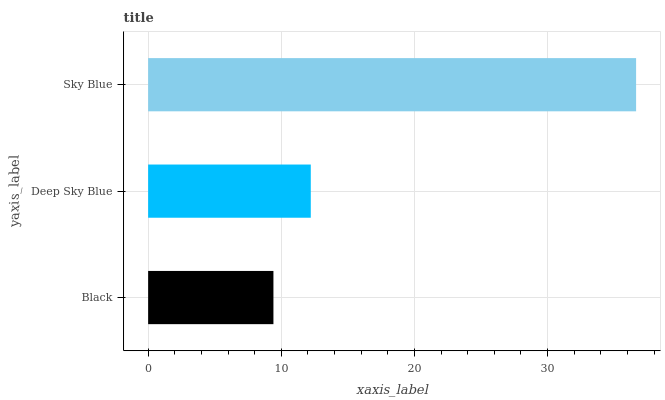Is Black the minimum?
Answer yes or no. Yes. Is Sky Blue the maximum?
Answer yes or no. Yes. Is Deep Sky Blue the minimum?
Answer yes or no. No. Is Deep Sky Blue the maximum?
Answer yes or no. No. Is Deep Sky Blue greater than Black?
Answer yes or no. Yes. Is Black less than Deep Sky Blue?
Answer yes or no. Yes. Is Black greater than Deep Sky Blue?
Answer yes or no. No. Is Deep Sky Blue less than Black?
Answer yes or no. No. Is Deep Sky Blue the high median?
Answer yes or no. Yes. Is Deep Sky Blue the low median?
Answer yes or no. Yes. Is Sky Blue the high median?
Answer yes or no. No. Is Sky Blue the low median?
Answer yes or no. No. 